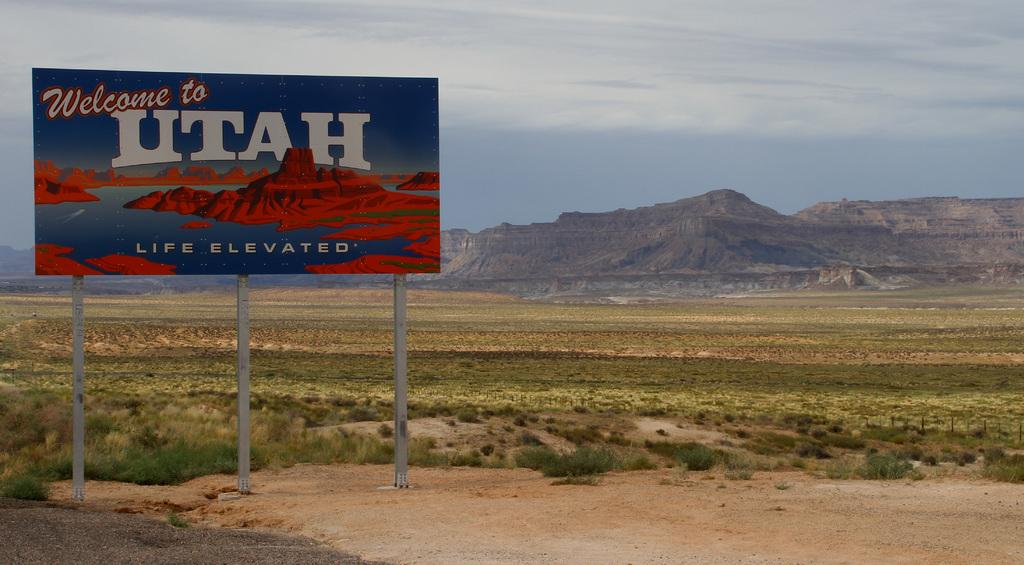<image>
Share a concise interpretation of the image provided. a billboard road sign that says 'welcome to utah' on it 